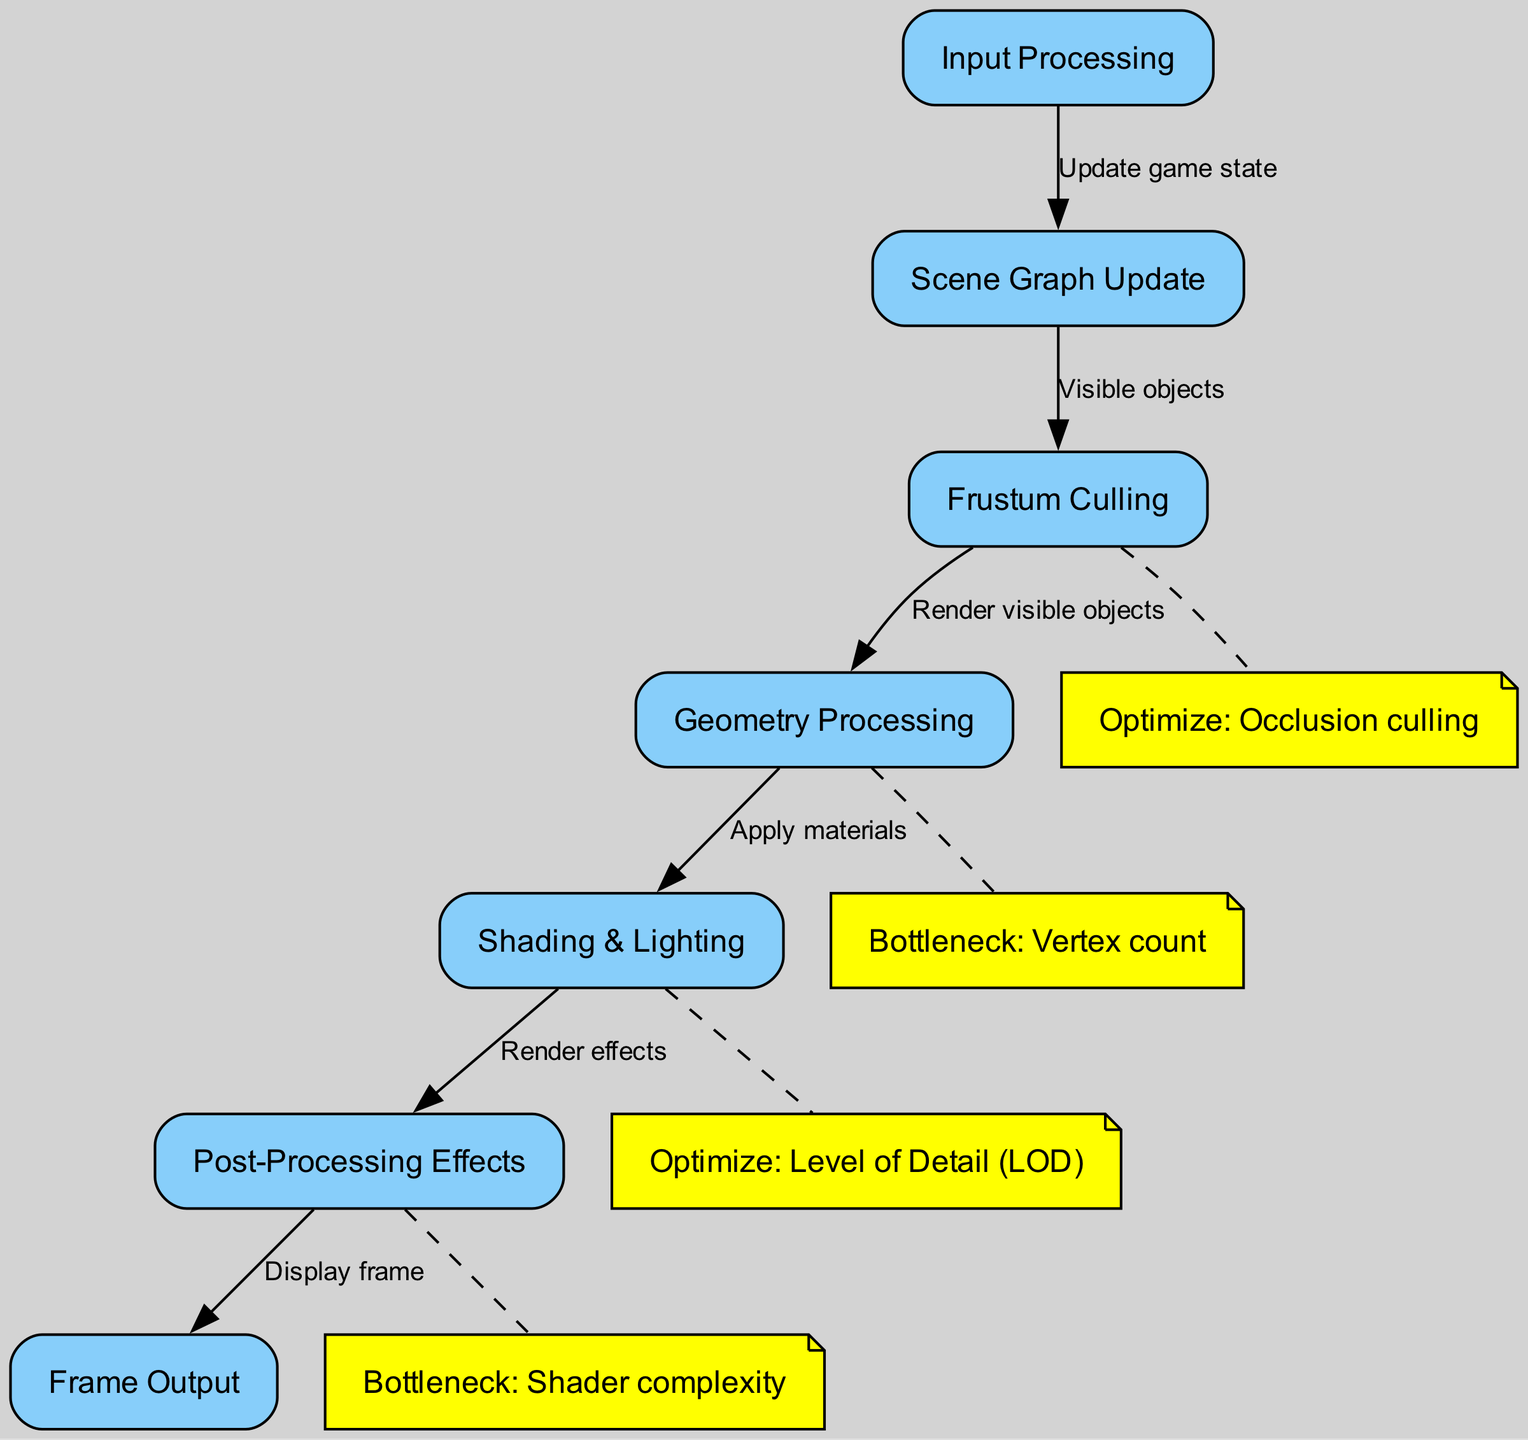What is the first step in the rendering pipeline? The first step in the rendering pipeline is "Input Processing," which is depicted as the initial node in the diagram and starts the flow of the rendering sequence.
Answer: Input Processing How many nodes are present in the diagram? The diagram consists of a total of six nodes, which include Input Processing, Scene Graph Update, Frustum Culling, Geometry Processing, Shading & Lighting, Post-Processing Effects, and Frame Output.
Answer: Six What is the label on the edge connecting "Shading & Lighting" and "Post-Processing Effects"? The edge connecting "Shading & Lighting" to "Post-Processing Effects" is labeled "Render effects," indicating the action taking place between these two nodes.
Answer: Render effects Which optimization is suggested for the "Culling" node? The optimization suggested for the "Culling" node is "Occlusion culling," which aims to improve performance by ignoring objects that are not visible in the current view.
Answer: Occlusion culling What is the bottleneck identified in the "Geometry Processing" node? The bottleneck identified in the "Geometry Processing" node is the "Vertex count," which indicates that the number of vertices can significantly impact performance and rendering speed.
Answer: Vertex count How does "Geometry Processing" relate to "Shading & Lighting"? "Geometry Processing" sends outputs to "Shading & Lighting" through an edge labeled "Apply materials," establishing a direct connection and workflow from geometry to shading.
Answer: Apply materials Which two nodes are identified as bottlenecks in the diagram? The two nodes identified as bottlenecks in the diagram are "Geometry Processing" with the bottleneck being "Vertex count," and "Post-Processing Effects" with the bottleneck labeled "Shader complexity."
Answer: Vertex count, Shader complexity What is the final step in the rendering pipeline? The final step in the rendering pipeline is "Frame Output," which signifies the end of the rendering process where the rendered frame is prepared for display.
Answer: Frame Output 